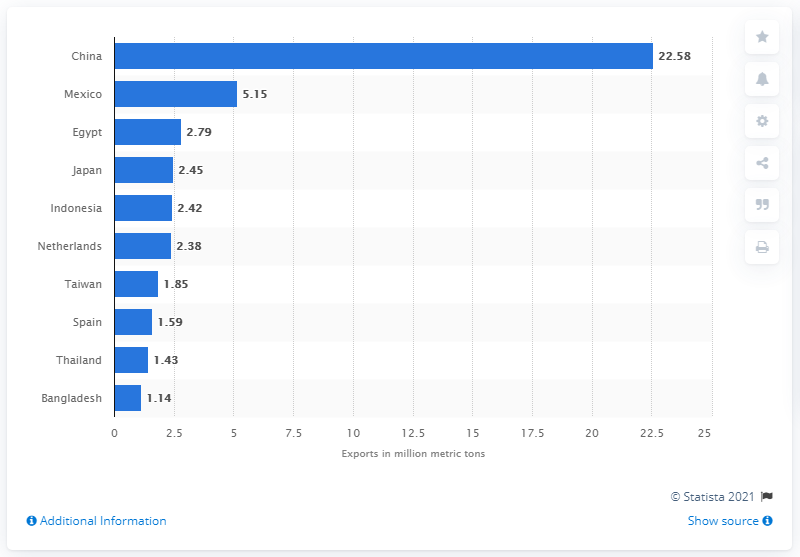Point out several critical features in this image. In 2019, China imported a total of 22,580 metric tons of soybeans from the United States. 